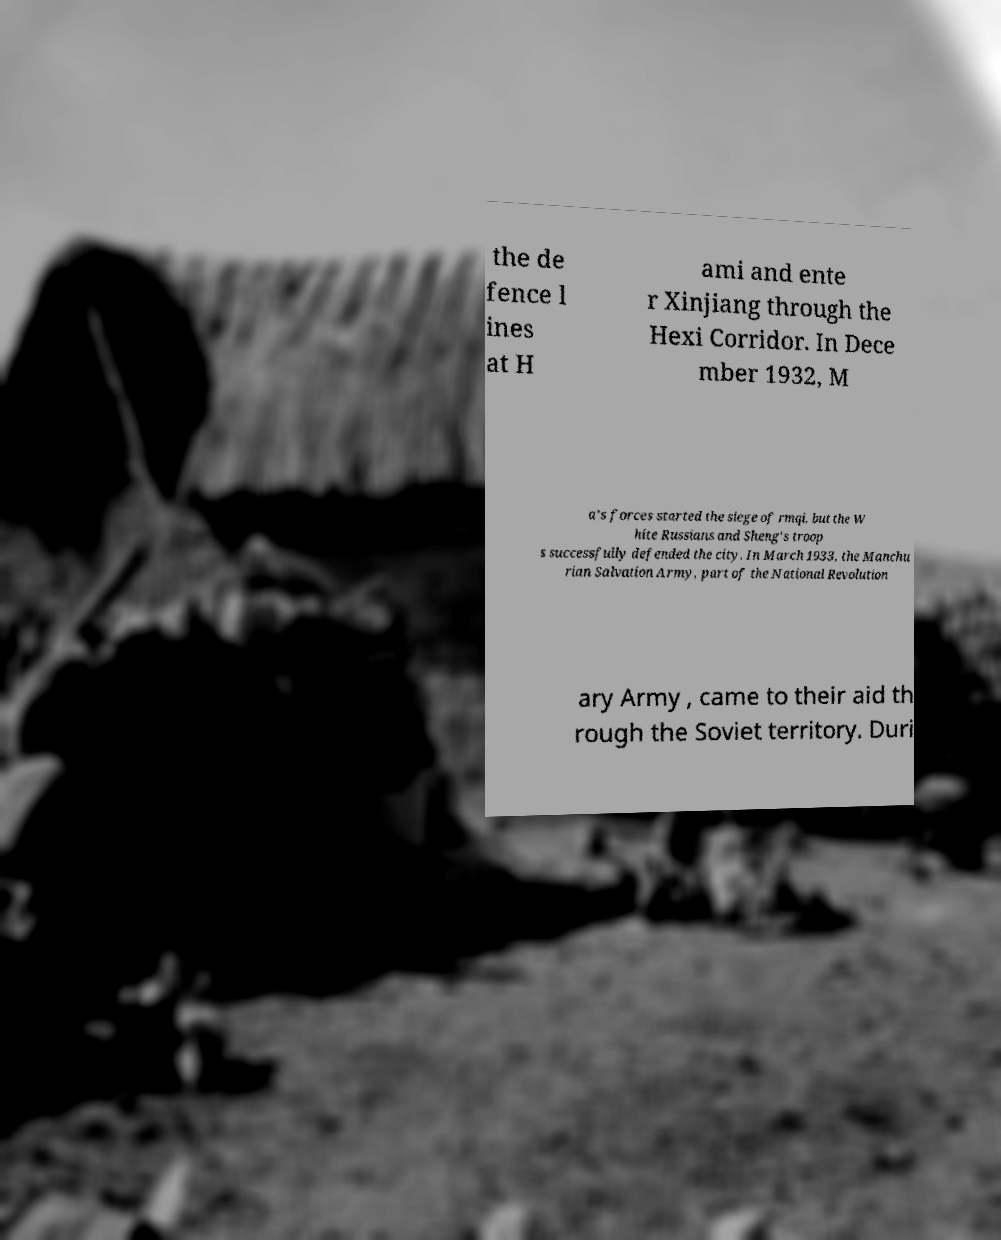Can you read and provide the text displayed in the image?This photo seems to have some interesting text. Can you extract and type it out for me? the de fence l ines at H ami and ente r Xinjiang through the Hexi Corridor. In Dece mber 1932, M a's forces started the siege of rmqi, but the W hite Russians and Sheng's troop s successfully defended the city. In March 1933, the Manchu rian Salvation Army, part of the National Revolution ary Army , came to their aid th rough the Soviet territory. Duri 